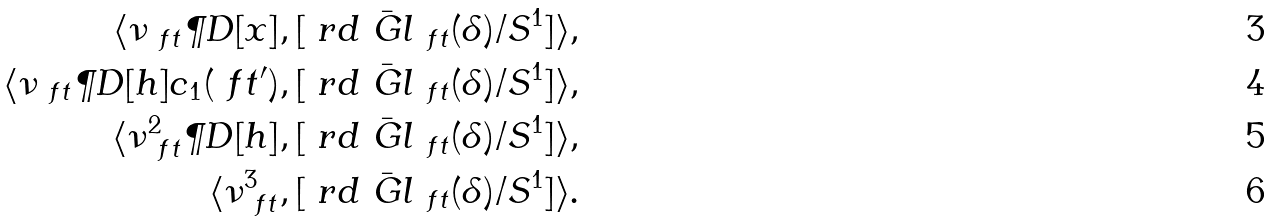Convert formula to latex. <formula><loc_0><loc_0><loc_500><loc_500>\langle \nu _ { \ f t } \P D [ x ] , [ \ r d \bar { \ G l } _ { \ f t } ( \delta ) / S ^ { 1 } ] \rangle , \\ \langle \nu _ { \ f t } \P D [ h ] c _ { 1 } ( \ f t ^ { \prime } ) , [ \ r d \bar { \ G l } _ { \ f t } ( \delta ) / S ^ { 1 } ] \rangle , \\ \langle \nu _ { \ f t } ^ { 2 } \P D [ h ] , [ \ r d \bar { \ G l } _ { \ f t } ( \delta ) / S ^ { 1 } ] \rangle , \\ \langle \nu _ { \ f t } ^ { 3 } , [ \ r d \bar { \ G l } _ { \ f t } ( \delta ) / S ^ { 1 } ] \rangle .</formula> 